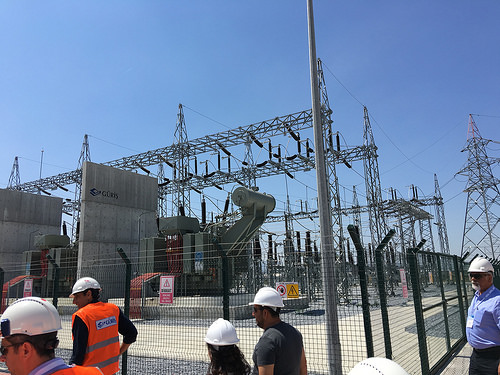<image>
Is the man to the left of the man? No. The man is not to the left of the man. From this viewpoint, they have a different horizontal relationship. Is there a man behind the fence? No. The man is not behind the fence. From this viewpoint, the man appears to be positioned elsewhere in the scene. 